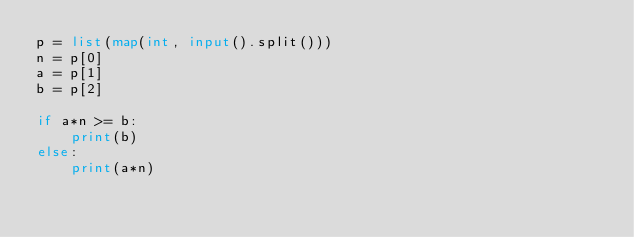<code> <loc_0><loc_0><loc_500><loc_500><_Python_>p = list(map(int, input().split()))
n = p[0]
a = p[1]
b = p[2]

if a*n >= b:
    print(b)
else:
    print(a*n)</code> 